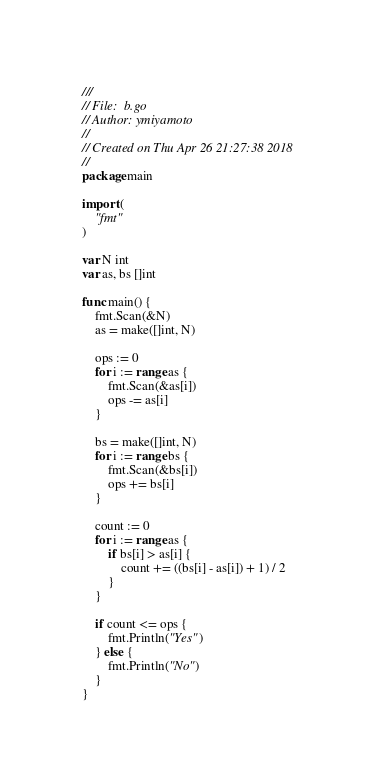<code> <loc_0><loc_0><loc_500><loc_500><_Go_>///
// File:  b.go
// Author: ymiyamoto
//
// Created on Thu Apr 26 21:27:38 2018
//
package main

import (
	"fmt"
)

var N int
var as, bs []int

func main() {
	fmt.Scan(&N)
	as = make([]int, N)

	ops := 0
	for i := range as {
		fmt.Scan(&as[i])
		ops -= as[i]
	}

	bs = make([]int, N)
	for i := range bs {
		fmt.Scan(&bs[i])
		ops += bs[i]
	}

	count := 0
	for i := range as {
		if bs[i] > as[i] {
			count += ((bs[i] - as[i]) + 1) / 2
		}
	}

	if count <= ops {
		fmt.Println("Yes")
	} else {
		fmt.Println("No")
	}
}
</code> 